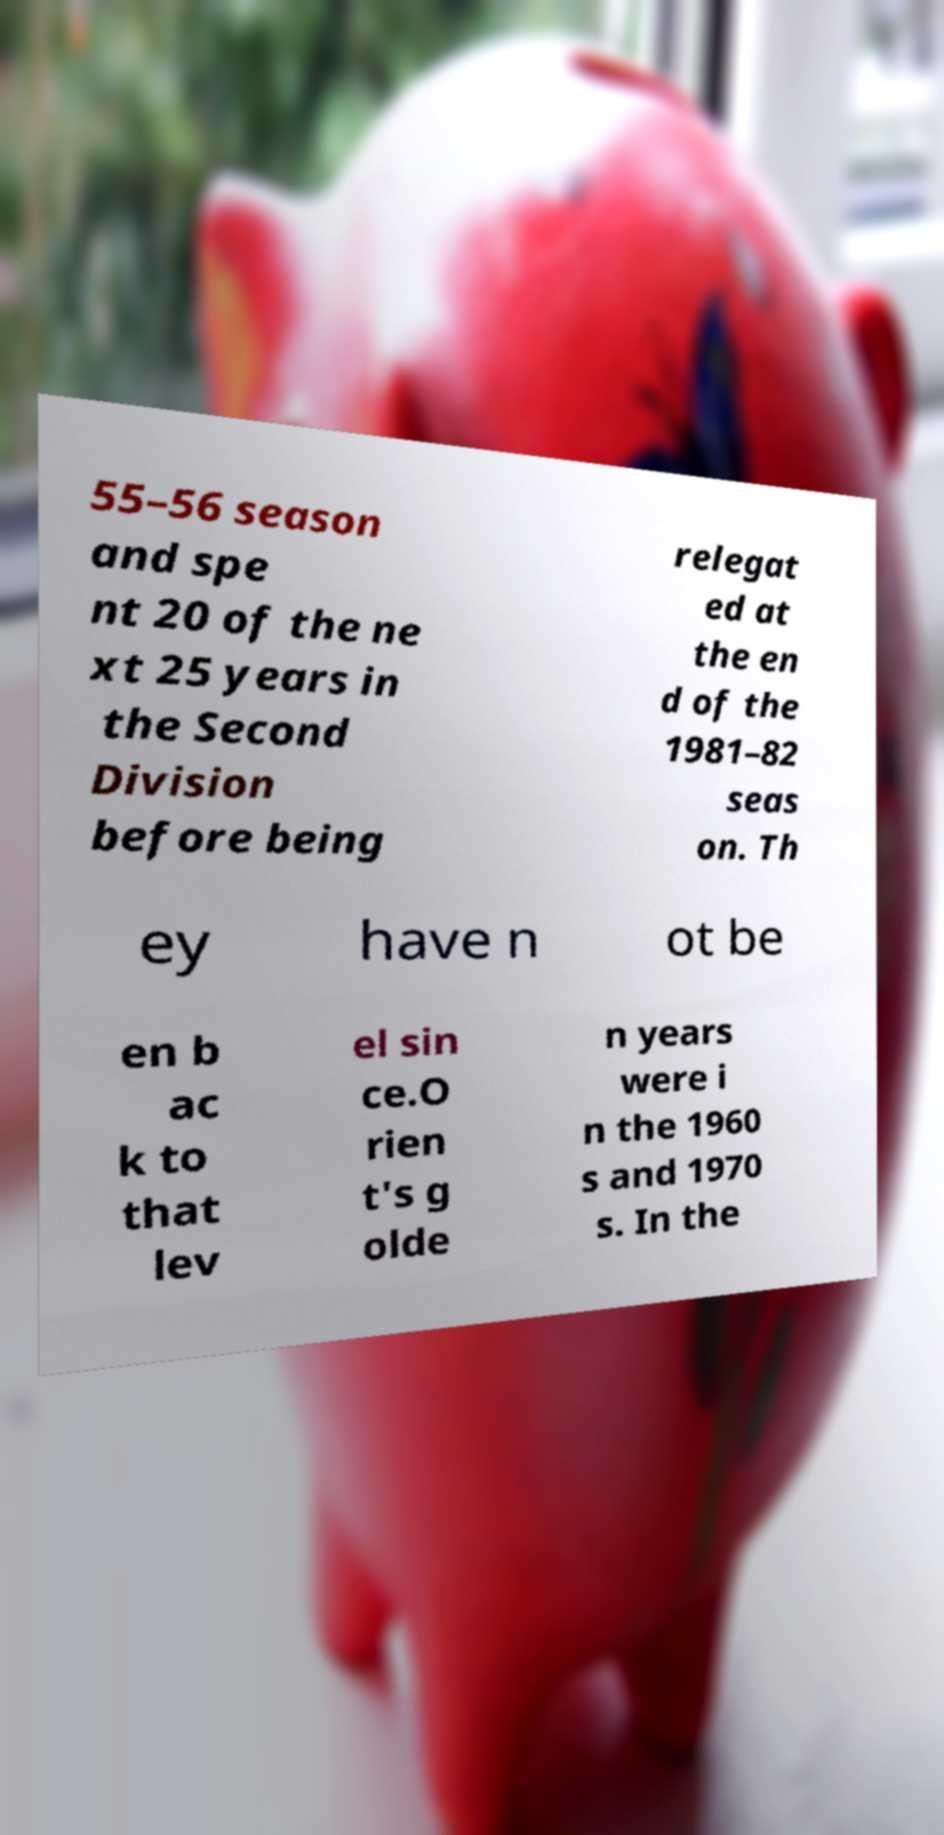For documentation purposes, I need the text within this image transcribed. Could you provide that? 55–56 season and spe nt 20 of the ne xt 25 years in the Second Division before being relegat ed at the en d of the 1981–82 seas on. Th ey have n ot be en b ac k to that lev el sin ce.O rien t's g olde n years were i n the 1960 s and 1970 s. In the 